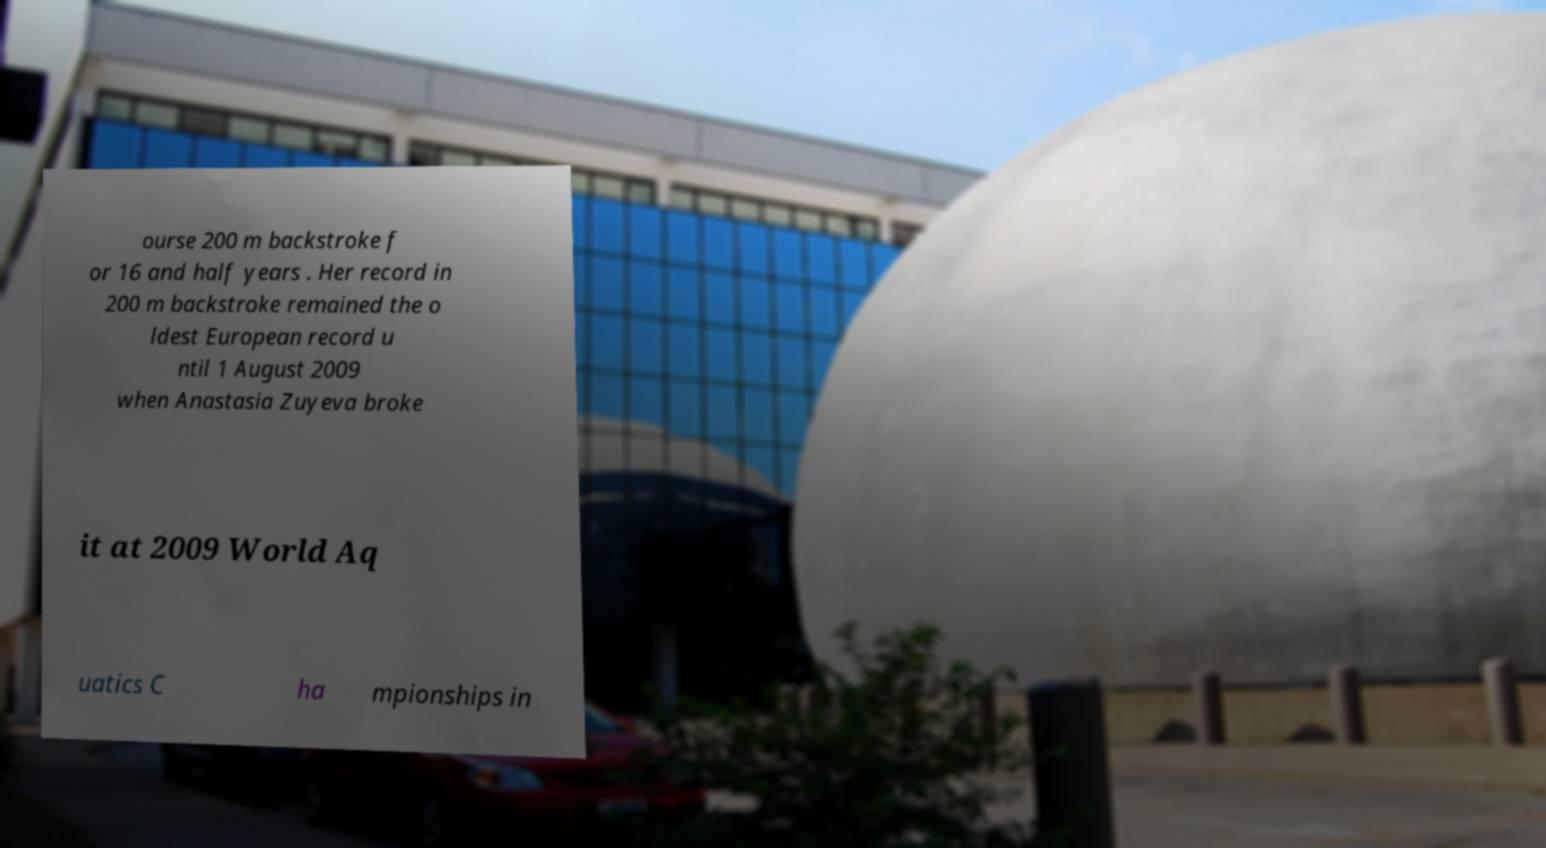Could you extract and type out the text from this image? ourse 200 m backstroke f or 16 and half years . Her record in 200 m backstroke remained the o ldest European record u ntil 1 August 2009 when Anastasia Zuyeva broke it at 2009 World Aq uatics C ha mpionships in 